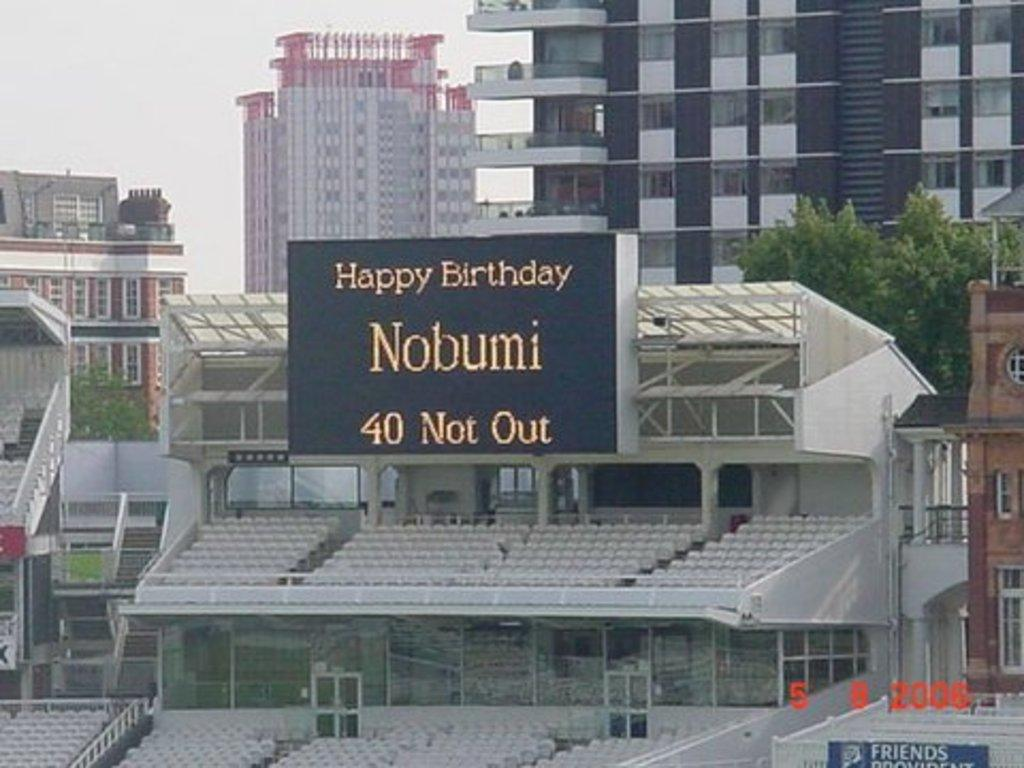<image>
Write a terse but informative summary of the picture. A huge black poster on top of a stadium that says Happy Birthday Nobumi. 